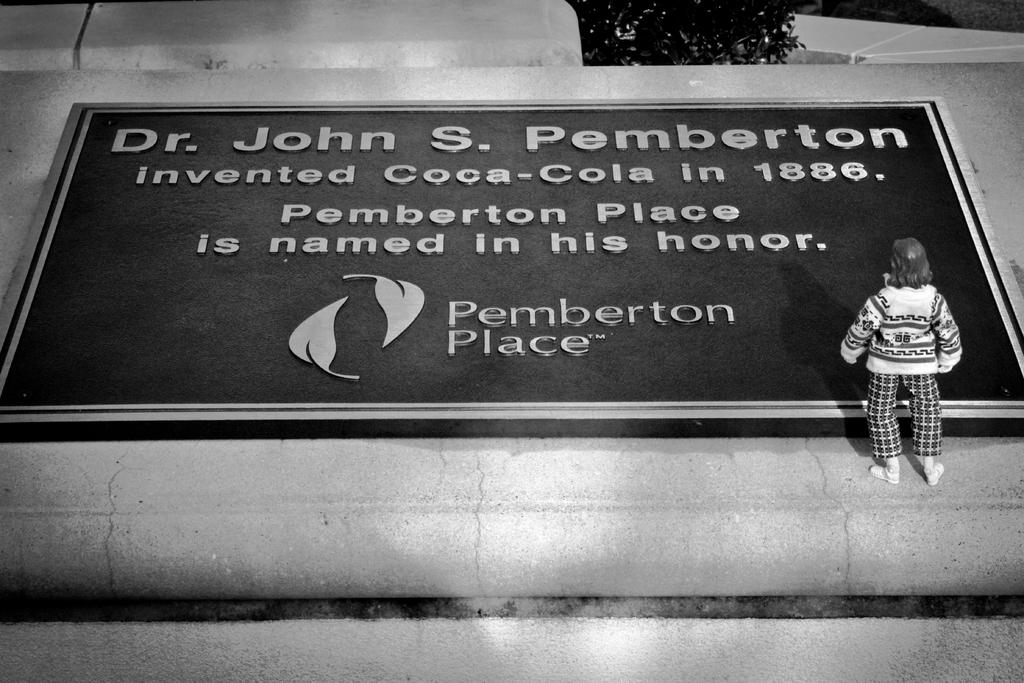What is the main object in the middle of the image? There is a board in the middle of the image. Who or what is on the right side of the image? There is a person standing on the right side of the image. What is the person doing or looking at? The person is looking at the board. What is the purpose of the committee meeting in the image? There is no committee or meeting present in the image; it only features a board and a person standing nearby. 